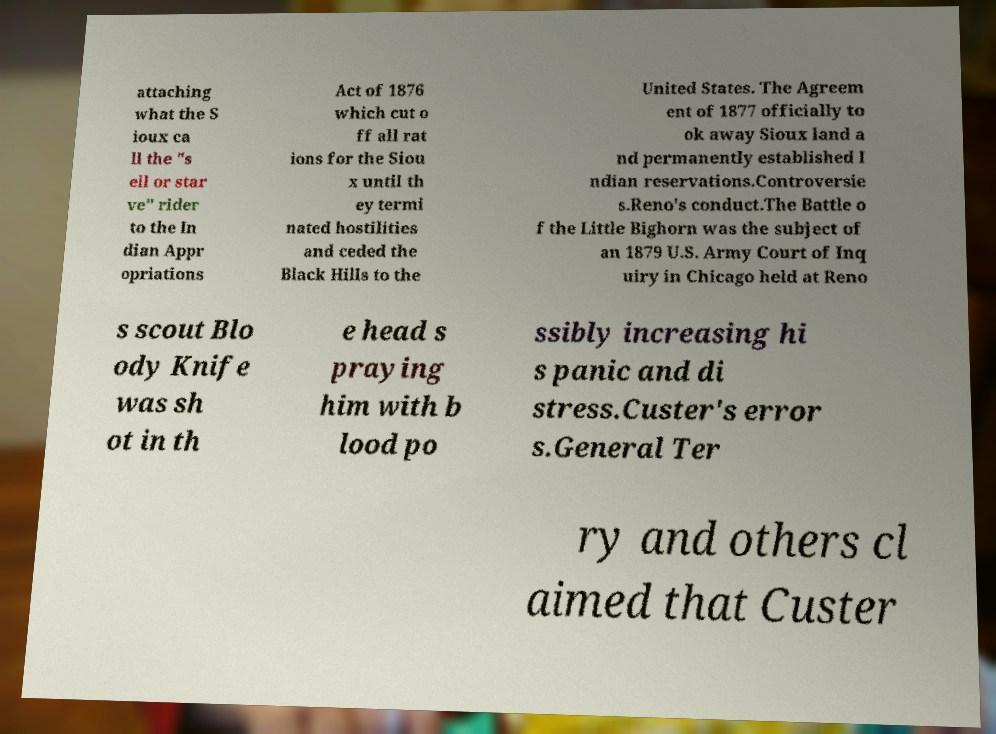Please identify and transcribe the text found in this image. attaching what the S ioux ca ll the "s ell or star ve" rider to the In dian Appr opriations Act of 1876 which cut o ff all rat ions for the Siou x until th ey termi nated hostilities and ceded the Black Hills to the United States. The Agreem ent of 1877 officially to ok away Sioux land a nd permanently established I ndian reservations.Controversie s.Reno's conduct.The Battle o f the Little Bighorn was the subject of an 1879 U.S. Army Court of Inq uiry in Chicago held at Reno s scout Blo ody Knife was sh ot in th e head s praying him with b lood po ssibly increasing hi s panic and di stress.Custer's error s.General Ter ry and others cl aimed that Custer 